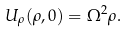Convert formula to latex. <formula><loc_0><loc_0><loc_500><loc_500>U _ { \rho } ( \rho , 0 ) = \Omega ^ { 2 } \rho .</formula> 